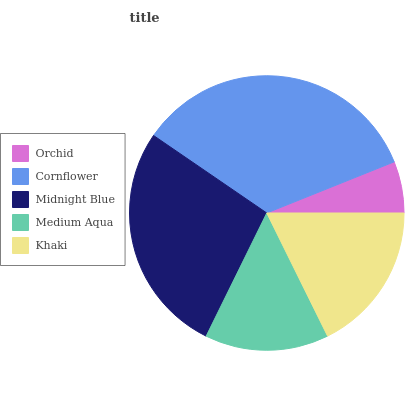Is Orchid the minimum?
Answer yes or no. Yes. Is Cornflower the maximum?
Answer yes or no. Yes. Is Midnight Blue the minimum?
Answer yes or no. No. Is Midnight Blue the maximum?
Answer yes or no. No. Is Cornflower greater than Midnight Blue?
Answer yes or no. Yes. Is Midnight Blue less than Cornflower?
Answer yes or no. Yes. Is Midnight Blue greater than Cornflower?
Answer yes or no. No. Is Cornflower less than Midnight Blue?
Answer yes or no. No. Is Khaki the high median?
Answer yes or no. Yes. Is Khaki the low median?
Answer yes or no. Yes. Is Cornflower the high median?
Answer yes or no. No. Is Midnight Blue the low median?
Answer yes or no. No. 